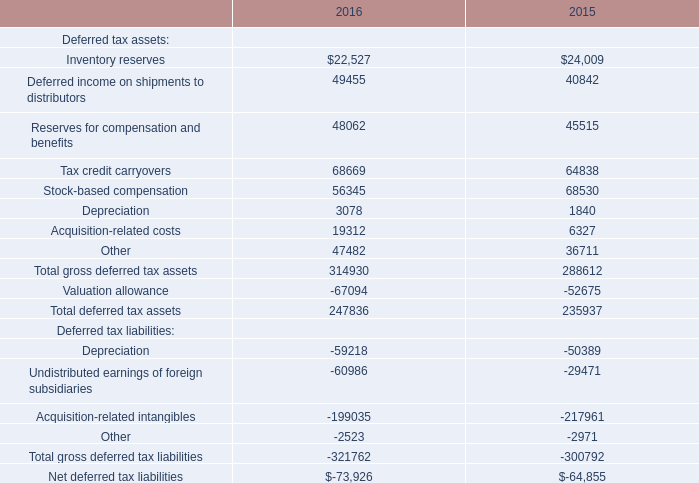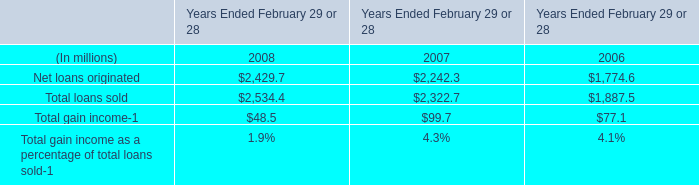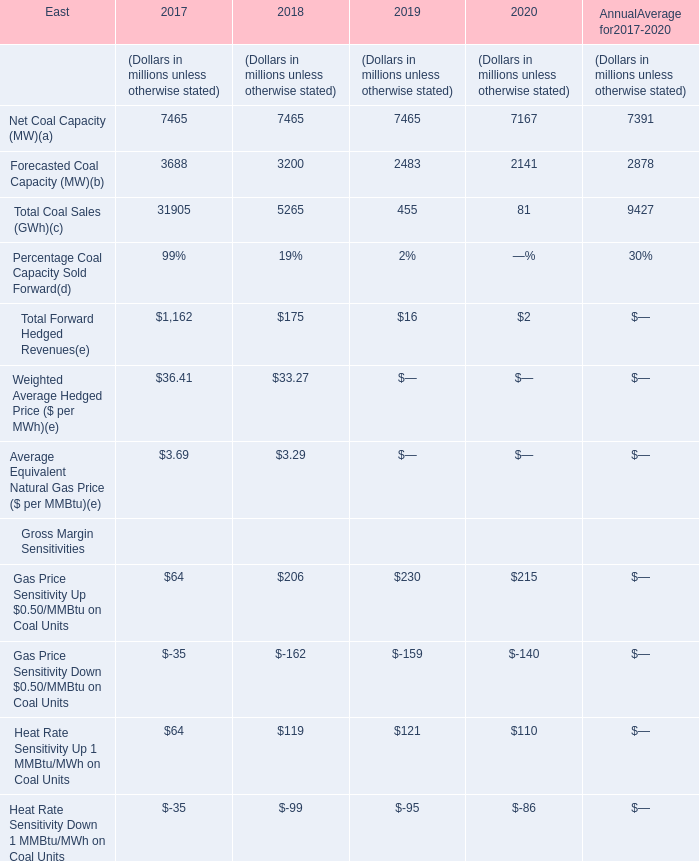What do all Gross Margin Sensitivities sum up, excluding those negative ones in 2019? (in million) 
Computations: (230 + 121)
Answer: 351.0. 